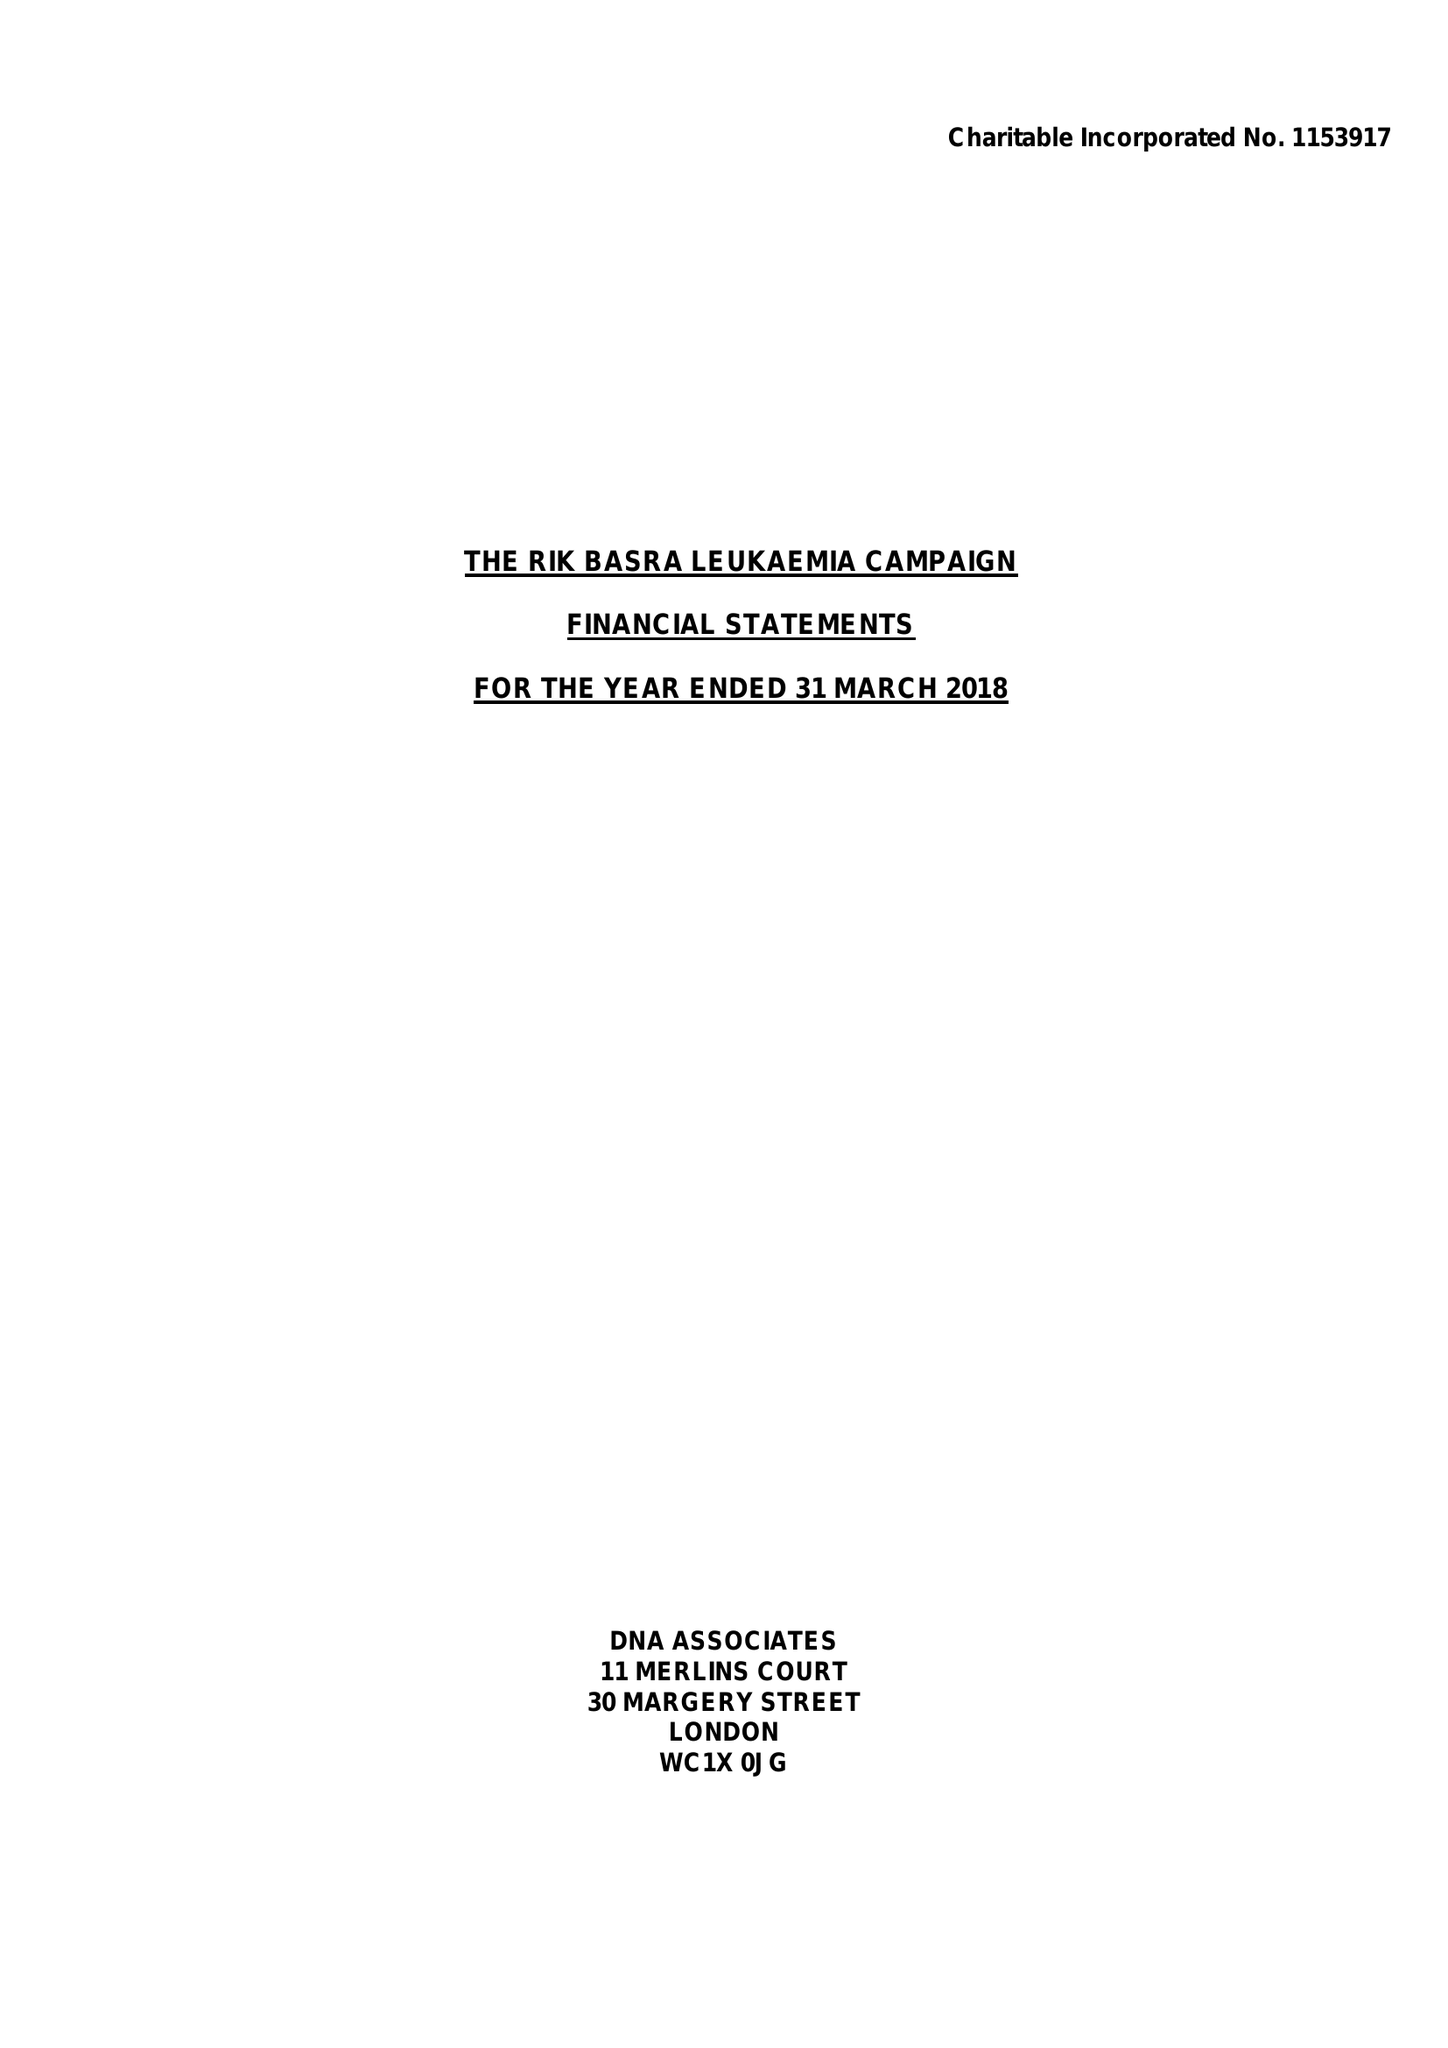What is the value for the address__post_town?
Answer the question using a single word or phrase. LEICESTER 